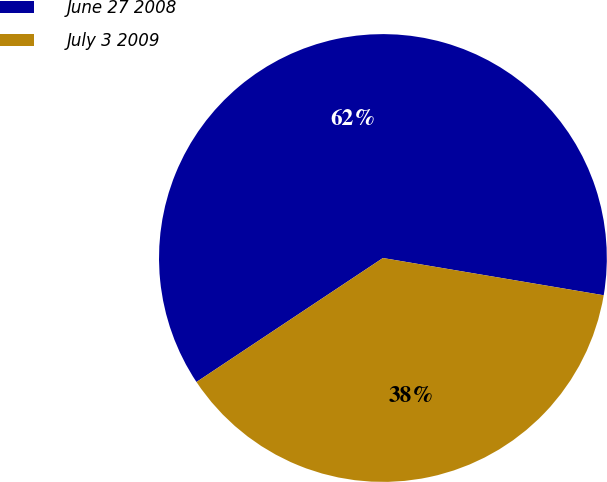Convert chart to OTSL. <chart><loc_0><loc_0><loc_500><loc_500><pie_chart><fcel>June 27 2008<fcel>July 3 2009<nl><fcel>62.0%<fcel>38.0%<nl></chart> 